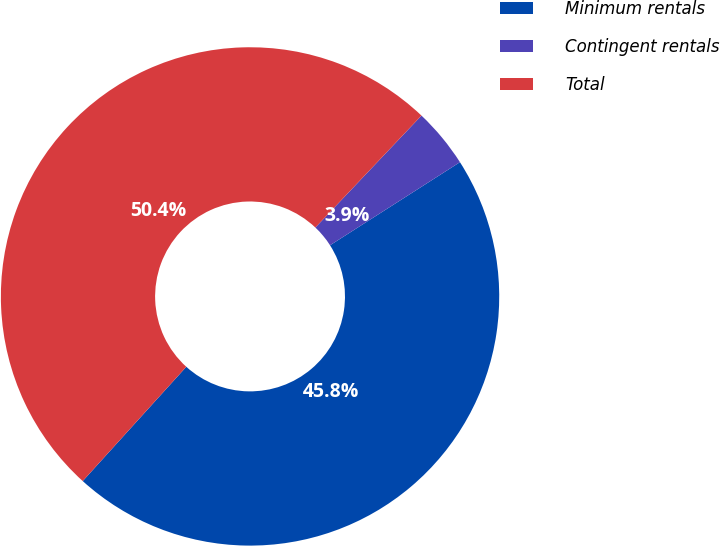Convert chart. <chart><loc_0><loc_0><loc_500><loc_500><pie_chart><fcel>Minimum rentals<fcel>Contingent rentals<fcel>Total<nl><fcel>45.78%<fcel>3.87%<fcel>50.36%<nl></chart> 